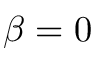<formula> <loc_0><loc_0><loc_500><loc_500>\beta = 0</formula> 